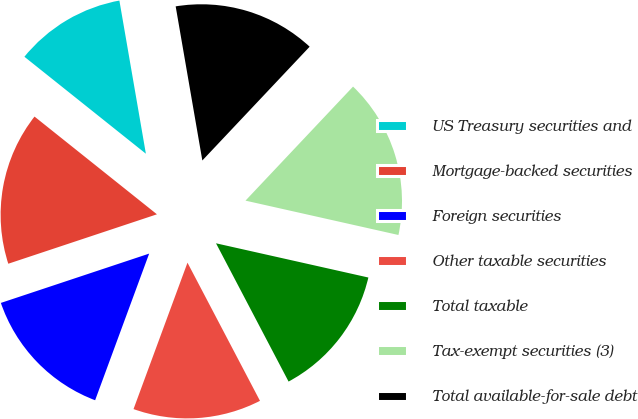<chart> <loc_0><loc_0><loc_500><loc_500><pie_chart><fcel>US Treasury securities and<fcel>Mortgage-backed securities<fcel>Foreign securities<fcel>Other taxable securities<fcel>Total taxable<fcel>Tax-exempt securities (3)<fcel>Total available-for-sale debt<nl><fcel>11.55%<fcel>15.83%<fcel>14.27%<fcel>13.31%<fcel>13.79%<fcel>16.48%<fcel>14.76%<nl></chart> 